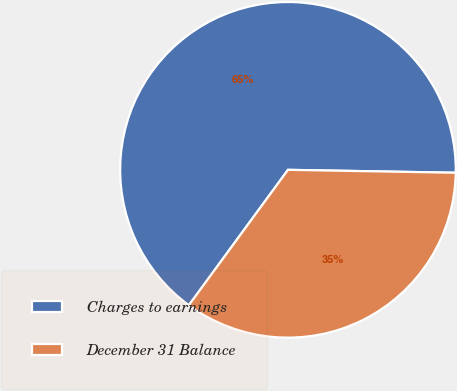<chart> <loc_0><loc_0><loc_500><loc_500><pie_chart><fcel>Charges to earnings<fcel>December 31 Balance<nl><fcel>65.22%<fcel>34.78%<nl></chart> 